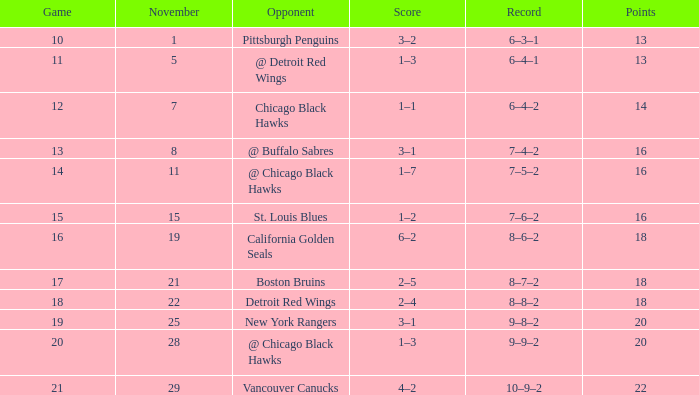Can you parse all the data within this table? {'header': ['Game', 'November', 'Opponent', 'Score', 'Record', 'Points'], 'rows': [['10', '1', 'Pittsburgh Penguins', '3–2', '6–3–1', '13'], ['11', '5', '@ Detroit Red Wings', '1–3', '6–4–1', '13'], ['12', '7', 'Chicago Black Hawks', '1–1', '6–4–2', '14'], ['13', '8', '@ Buffalo Sabres', '3–1', '7–4–2', '16'], ['14', '11', '@ Chicago Black Hawks', '1–7', '7–5–2', '16'], ['15', '15', 'St. Louis Blues', '1–2', '7–6–2', '16'], ['16', '19', 'California Golden Seals', '6–2', '8–6–2', '18'], ['17', '21', 'Boston Bruins', '2–5', '8–7–2', '18'], ['18', '22', 'Detroit Red Wings', '2–4', '8–8–2', '18'], ['19', '25', 'New York Rangers', '3–1', '9–8–2', '20'], ['20', '28', '@ Chicago Black Hawks', '1–3', '9–9–2', '20'], ['21', '29', 'Vancouver Canucks', '4–2', '10–9–2', '22']]} Which rival has a point total less than 18, and a november larger than 11? St. Louis Blues. 